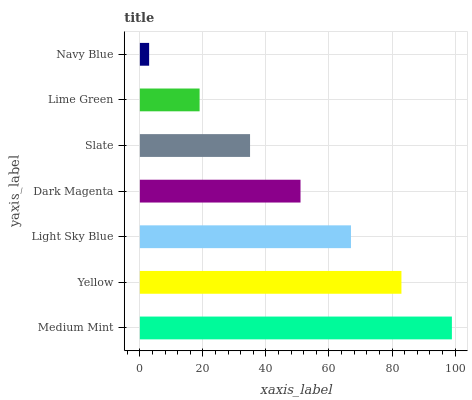Is Navy Blue the minimum?
Answer yes or no. Yes. Is Medium Mint the maximum?
Answer yes or no. Yes. Is Yellow the minimum?
Answer yes or no. No. Is Yellow the maximum?
Answer yes or no. No. Is Medium Mint greater than Yellow?
Answer yes or no. Yes. Is Yellow less than Medium Mint?
Answer yes or no. Yes. Is Yellow greater than Medium Mint?
Answer yes or no. No. Is Medium Mint less than Yellow?
Answer yes or no. No. Is Dark Magenta the high median?
Answer yes or no. Yes. Is Dark Magenta the low median?
Answer yes or no. Yes. Is Medium Mint the high median?
Answer yes or no. No. Is Lime Green the low median?
Answer yes or no. No. 